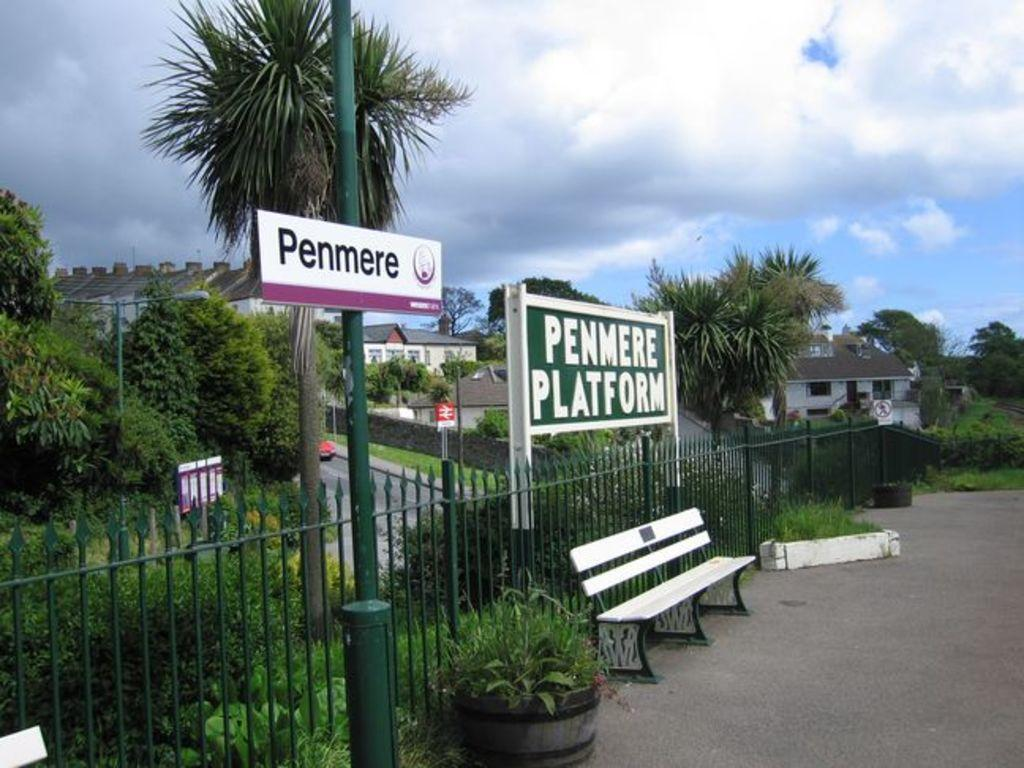What type of seating is visible in the image? There is a bench in the image. What other objects can be seen in the image? There are plants and fencing visible in the image. What type of vegetation is present in the area? There are trees in the area. What structures can be seen in the area? There are buildings in the area. What is the condition of the sky in the image? The sky is clear in the image. What type of jam is being spread on the orange in the image? There is no jam or orange present in the image. What force is being applied to the bench in the image? There is no force being applied to the bench in the image; it is stationary. 